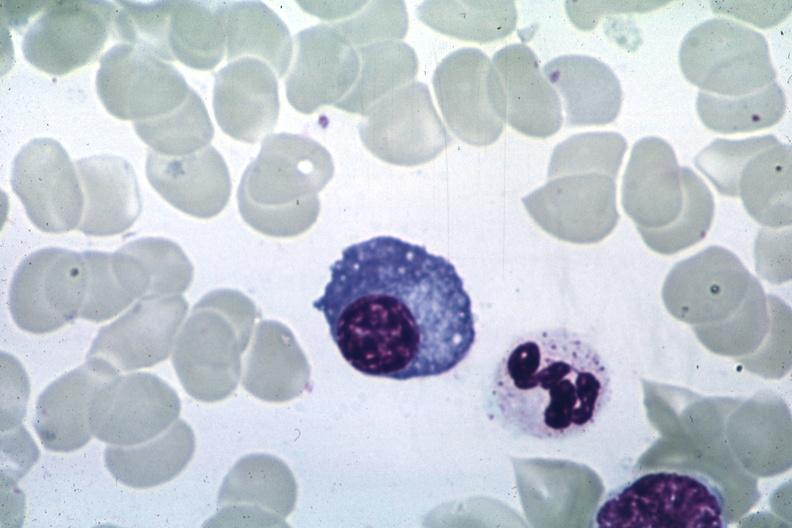does this image show wrights?
Answer the question using a single word or phrase. Yes 